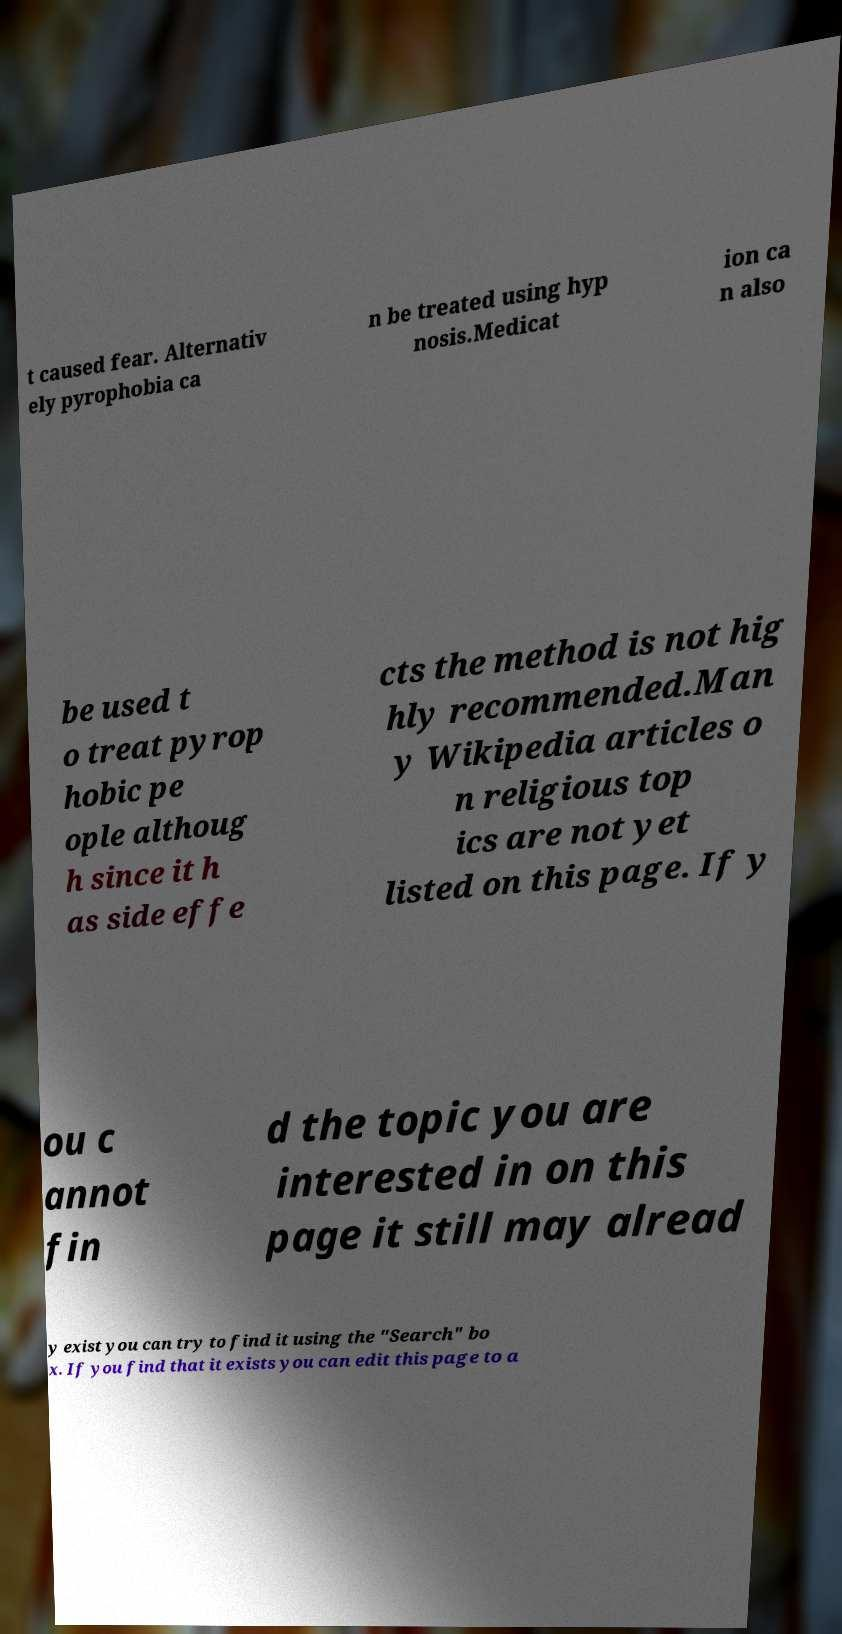Could you assist in decoding the text presented in this image and type it out clearly? t caused fear. Alternativ ely pyrophobia ca n be treated using hyp nosis.Medicat ion ca n also be used t o treat pyrop hobic pe ople althoug h since it h as side effe cts the method is not hig hly recommended.Man y Wikipedia articles o n religious top ics are not yet listed on this page. If y ou c annot fin d the topic you are interested in on this page it still may alread y exist you can try to find it using the "Search" bo x. If you find that it exists you can edit this page to a 